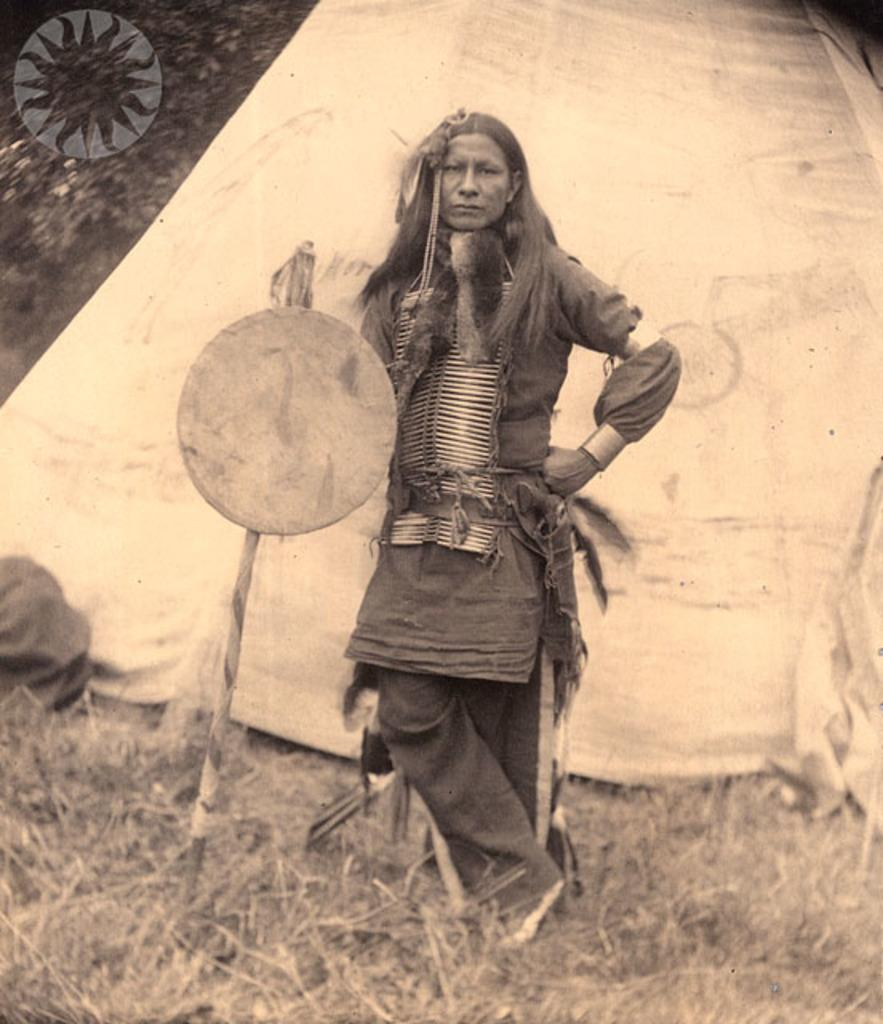What is the woman doing in the image? The woman is standing on the grass in the image. What type of shelter is visible in the image? There is a tent in the image. What object can be seen in the woman's hand? There is a stick in the image. What type of vegetation is present in the image? Leaves are present in the image. Can you describe any other objects in the image? There are other objects in the image, but their specific details are not mentioned in the provided facts. What type of cheese is being grated on the woman's head in the image? There is no cheese present in the image, and the woman's head is not being used for grating cheese. 